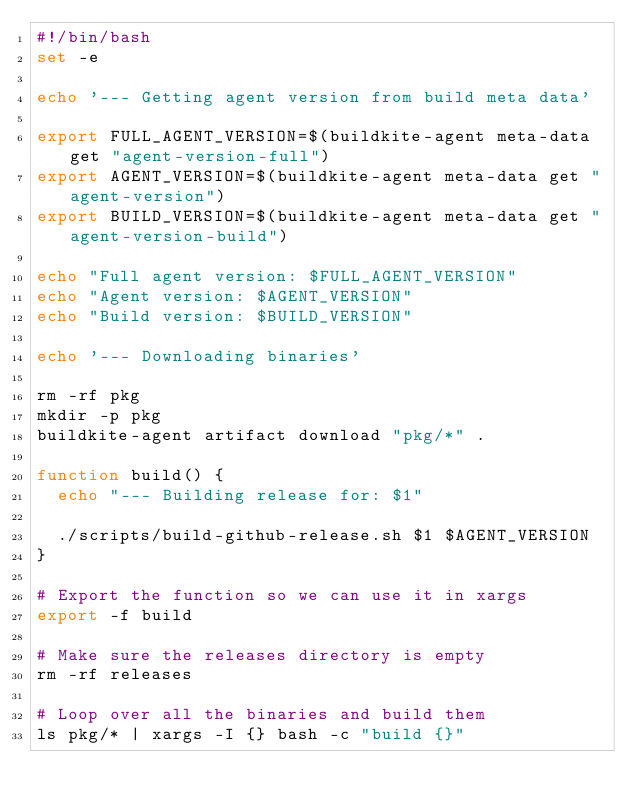<code> <loc_0><loc_0><loc_500><loc_500><_Bash_>#!/bin/bash
set -e

echo '--- Getting agent version from build meta data'

export FULL_AGENT_VERSION=$(buildkite-agent meta-data get "agent-version-full")
export AGENT_VERSION=$(buildkite-agent meta-data get "agent-version")
export BUILD_VERSION=$(buildkite-agent meta-data get "agent-version-build")

echo "Full agent version: $FULL_AGENT_VERSION"
echo "Agent version: $AGENT_VERSION"
echo "Build version: $BUILD_VERSION"

echo '--- Downloading binaries'

rm -rf pkg
mkdir -p pkg
buildkite-agent artifact download "pkg/*" .

function build() {
  echo "--- Building release for: $1"

  ./scripts/build-github-release.sh $1 $AGENT_VERSION
}

# Export the function so we can use it in xargs
export -f build

# Make sure the releases directory is empty
rm -rf releases

# Loop over all the binaries and build them
ls pkg/* | xargs -I {} bash -c "build {}"
</code> 